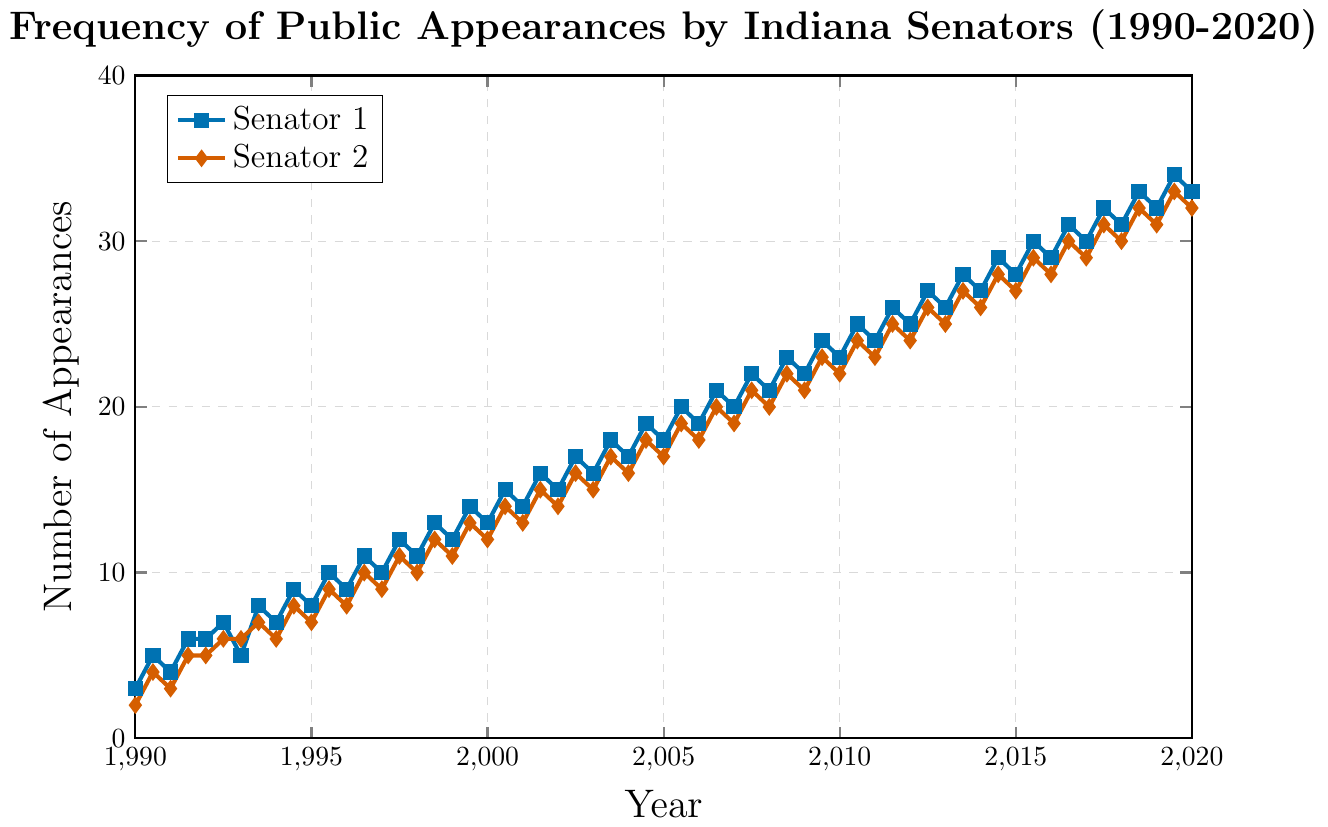What year did Senator 1 first surpass 20 public appearances in a single month? To determine the year Senator 1 first surpassed 20 appearances, observe the trend line for the blue data points. In 2005, the chart shows a data point slightly above 20.
Answer: 2005 Which senator had more appearances in 2010, and by how much? Compare the values for Senator 1 and Senator 2 in 2010. Senator 1 had 23 and 25 in June and December, while Senator 2 had 24 and 22. In December, Senator 1 had 23, and Senator 2 had 22. Therefore, Senator 1 had more by 1.
Answer: Senator 1 by 1 What is the overall trend for Senator 2’s public appearances from 1990 to 2020? Observing the red data points, we note a generally upward trend from 2 appearances in 1990, increasing to 34 by 2020, indicating a steady increase over the years.
Answer: Steady increase How much did Senator 1’s appearances increase from 1990 to 2020? Calculate the difference in Senator 1’s appearances from the start of 1990 to the end of 2020. In 1990, it was 3; in 2020, it was 33. So the increase is 33 - 3.
Answer: 30 During which years did both senators show a noticeable increase simultaneously in their appearances around June and December? Check the plots for both blue and red points, looking for simultaneous upward trends around mid-year and year-end. Noticeable synchronizations occurred in 1995, 2002, and 2010.
Answer: 1995, 2002, 2010 What is the difference in the number of appearances between Senator 1 and Senator 2 in June 2004? Check the values for both senators in June 2004. Senator 1 had 19 appearances, and Senator 2 had 18. So, the difference is 19 - 18.
Answer: 1 What years did both senators have exactly the same number of appearances? Look for overlapping data points. Both senators had the same appearance numbers in June 1992, December 2001, and June 2016.
Answer: 1992, 2001, 2016 On average, how many appearances did Senator 1 make per month in 1999? Calculate the average from 1999's data points: (6 in January, 14 in June, 12 in December). The sum is 6 + 14 + 12 = 32; the average is 32 / 3.
Answer: ~10.67 How did the maximum number of appearances in a month compare between the two senators in 2020? Find the maximum appearances for each senator in 2020. Senator 1 had a maximum of 35 appearances, while Senator 2 had a maximum of 34. Senator 1 had one more.
Answer: Senator 1 by 1 Which senator showed a more consistent increase without decreasing at any point from 1990, and what might this indicate? Look for the senator’s line that consistently rises without falling. Senator 1's line does not drop, indicating a steady rise. This might suggest a growing or ongoing commitment to public engagement for Senator 1.
Answer: Senator 1 